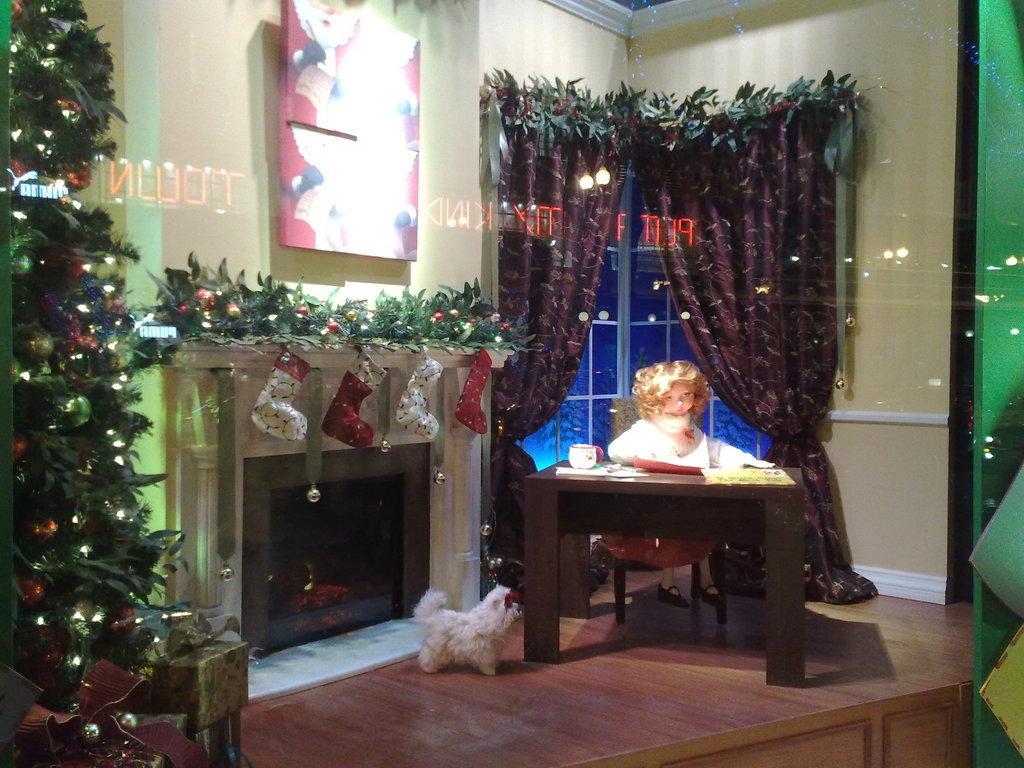Could you give a brief overview of what you see in this image? In this image I can see a doll,cup on the table. On the floor there is a dog and there is Christmas tree. 